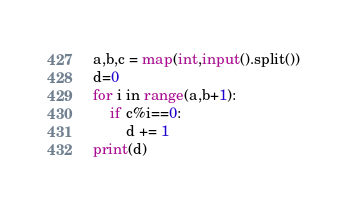<code> <loc_0><loc_0><loc_500><loc_500><_Python_>a,b,c = map(int,input().split())
d=0
for i in range(a,b+1):
    if c%i==0:
        d += 1
print(d)
</code> 